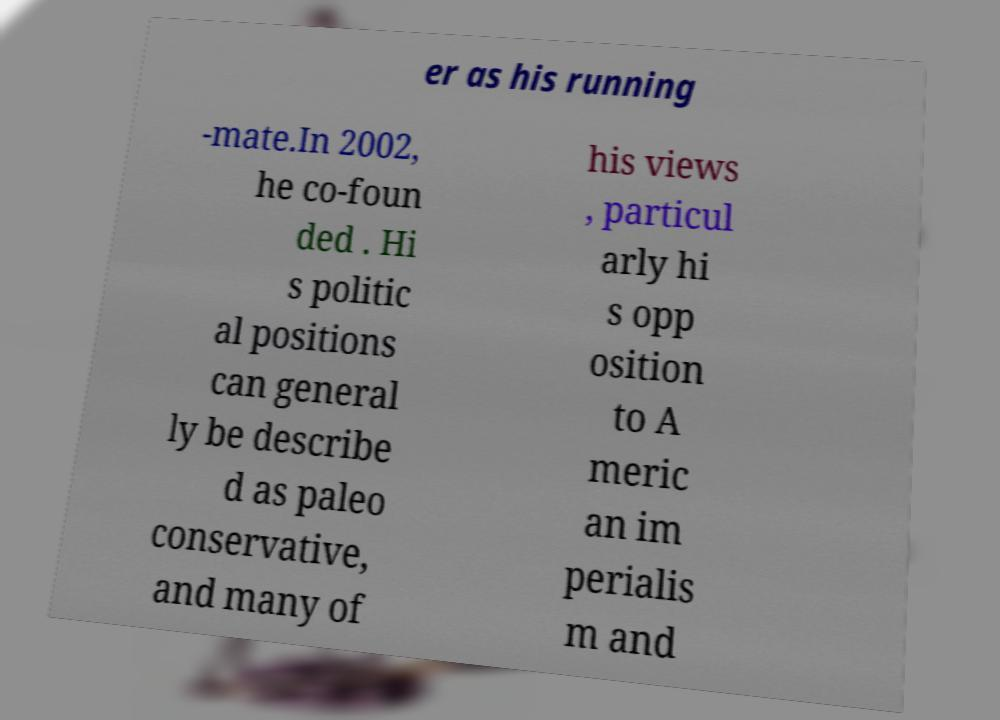What messages or text are displayed in this image? I need them in a readable, typed format. er as his running -mate.In 2002, he co-foun ded . Hi s politic al positions can general ly be describe d as paleo conservative, and many of his views , particul arly hi s opp osition to A meric an im perialis m and 